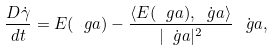<formula> <loc_0><loc_0><loc_500><loc_500>\frac { D \dot { \gamma } } { d t } = E ( \ g a ) - \frac { \langle E ( \ g a ) , \dot { \ g a } \rangle } { | \dot { \ g a } | ^ { 2 } } \, \dot { \ g a } ,</formula> 